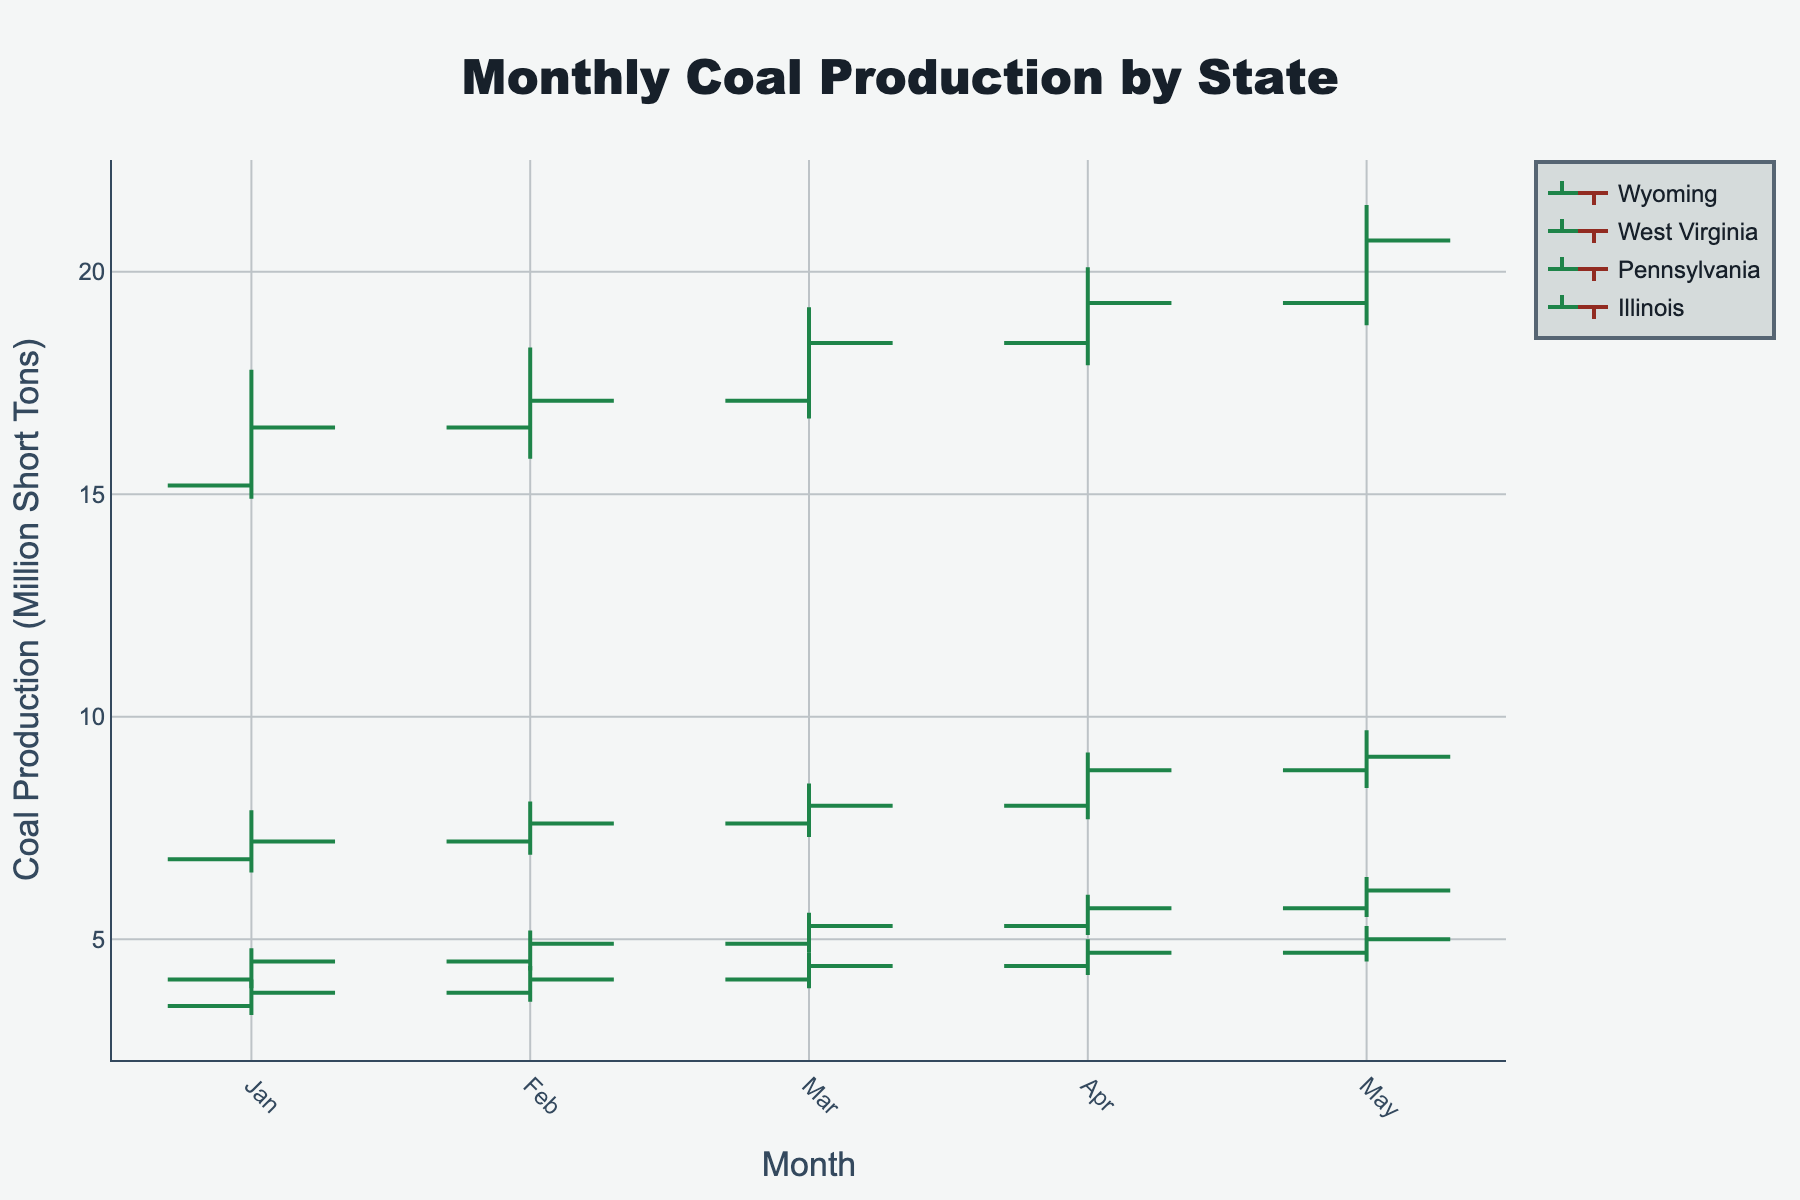what does the title of the chart indicate? The title of the chart, "Monthly Coal Production by State," indicates that the chart displays coal production levels on a monthly basis for different states over a certain period.
Answer: Monthly Coal Production by State How many states are represented in the chart? By looking at the different colored lines labeled on the plot, we can see that there are four states represented in the chart.
Answer: Four What is the Y-axis measuring? The Y-axis is labeled "Coal Production (Million Short Tons)," indicating that it measures the amount of coal produced in millions of short tons.
Answer: Coal Production (Million Short Tons) Which month had the lowest closing coal production for Wyoming? By examining Wyoming’s OHLC data series, we find that January had the lowest closing at 16.5.
Answer: January What color indicates increasing coal production in the chart? As indicated by the plot legend and OHLC bars, increasing coal production is shown using a greenish color.
Answer: Greenish Which state had the highest coal production peak, and in which month? Comparing the highest points (High values) among the states, Wyoming reached the highest production peak, which was 21.5 in May.
Answer: Wyoming, May Calculate the average closing coal production for Illinois from January to May. Calculate the closing values and then find the average: 
(3.8 + 4.1 + 4.4 + 4.7 + 5.0) / 5 = 22 / 5 = 4.4
Answer: 4.4 Compare the total coal production increase from January to May for Pennsylvania and West Virginia. Which state has the greater increase? Total increase for Pennsylvania: 6.1 - 4.5 = 1.6. Total increase for West Virginia: 9.1 - 7.2 = 1.9. Comparing the increases, West Virginia has the greater increase at 1.9.
Answer: West Virginia Describe the trend in coal production for Wyoming across the months displayed in the chart. By observing the OHLC bars for Wyoming, the overall trend shows a consistent increase in coal production, as indicated by general upward movements in the closing values from January to May.
Answer: Increasing 